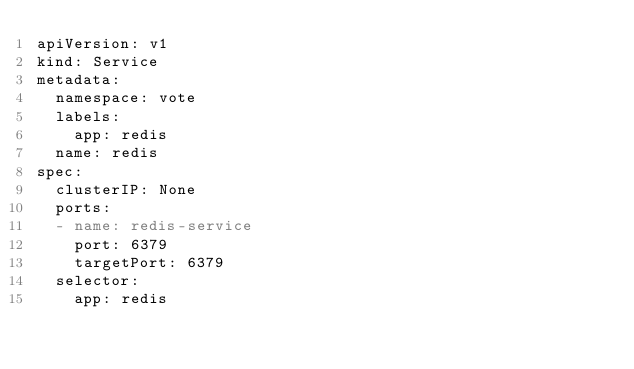<code> <loc_0><loc_0><loc_500><loc_500><_YAML_>apiVersion: v1
kind: Service
metadata: 
  namespace: vote
  labels: 
    app: redis
  name: redis
spec: 
  clusterIP: None
  ports:
  - name: redis-service
    port: 6379
    targetPort: 6379
  selector: 
    app: redis</code> 